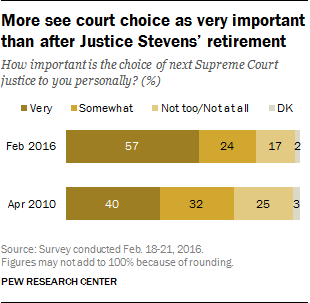Indicate a few pertinent items in this graphic. The sum of the two smallest bars is multiplied by 10 and the result is compared to the largest bar. If the result is less than the largest bar, then the largest bar is not greater than the sum of the smallest two bars. The value of the smallest bar is 2. 